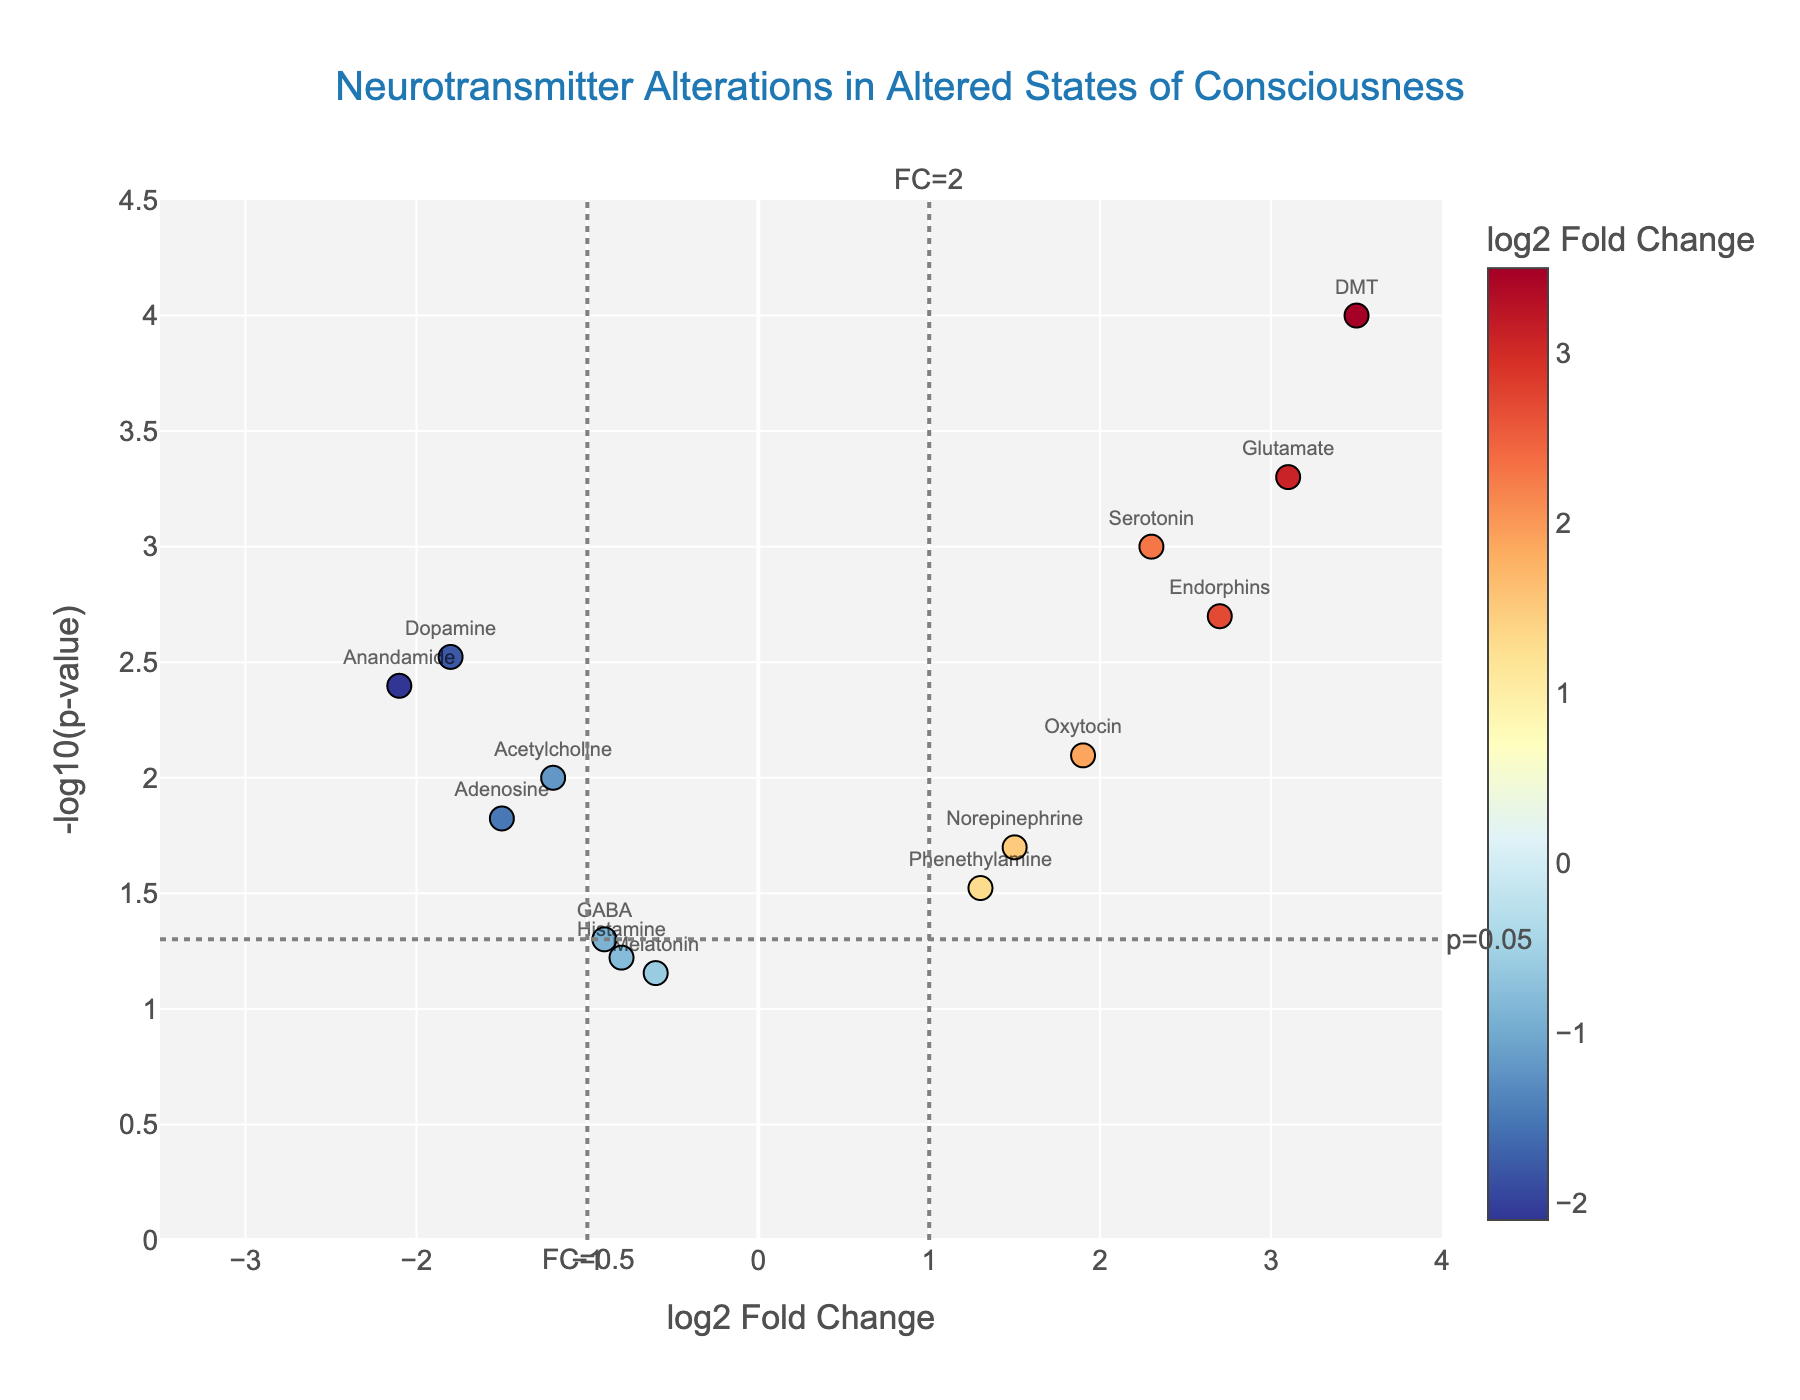What is the title of the figure? The title of the figure is indicated at the top of the plot and in larger, bolder text compared to other elements.
Answer: Neurotransmitter Alterations in Altered States of Consciousness How many neurotransmitters are shown in the plot? Count the number of unique data points (markers) in the plot. Each marker corresponds to a neurotransmitter.
Answer: 14 Which neurotransmitter has the highest log2 Fold Change? Look for the data point with the highest x-axis value, which represents the log2 Fold Change.
Answer: DMT What is the p-value threshold line, and where is it placed? The p-value threshold line is a horizontal line marked "p=0.05". It represents a -log10(p-value) of 1.3, as -log10(0.05) ≈ 1.3.
Answer: -log10(p-value) = 1.3 Which neurotransmitters have log2 Fold Change greater than 2? Identify the data points with an x-axis value greater than 2. These points are to the right of the vertical line marked "FC=2".
Answer: Serotonin, Glutamate, Endorphins, DMT Which neurotransmitter has the lowest p-value? Look for the data point with the highest y-axis value, as -log10(p-value) is highest for the smallest p-value.
Answer: DMT Compare the log2 Fold Change values of Serotonin and Dopamine. Which one is greater? Locate the points for Serotonin and Dopamine on the x-axis and compare their values. Serotonin should have a positive value while Dopamine should have a negative one.
Answer: Serotonin Which neurotransmitter has a -log10(p-value) close to the significance threshold at p=0.05 but does not exceed it? Look for a data point whose y-axis value is just below the horizontal line at -log10(p-value) ≈ 1.3. This is the significance threshold line.
Answer: Melatonin Name the neurotransmitters with fold changes between 0.5 and 2.0. Identify the data points with x-axis values between -1 and 1, as these represent fold changes between 0.5 and 2.0.
Answer: GABA, Acetylcholine, Melatonin, Oxytocin, Histamine Which neurotransmitter shows the largest negative log2 Fold Change, and what is its p-value? Identify the data point with the lowest x-axis value (leftmost) and check its associated p-value by its y-axis value or hover text information.
Answer: Anandamide, 0.004 